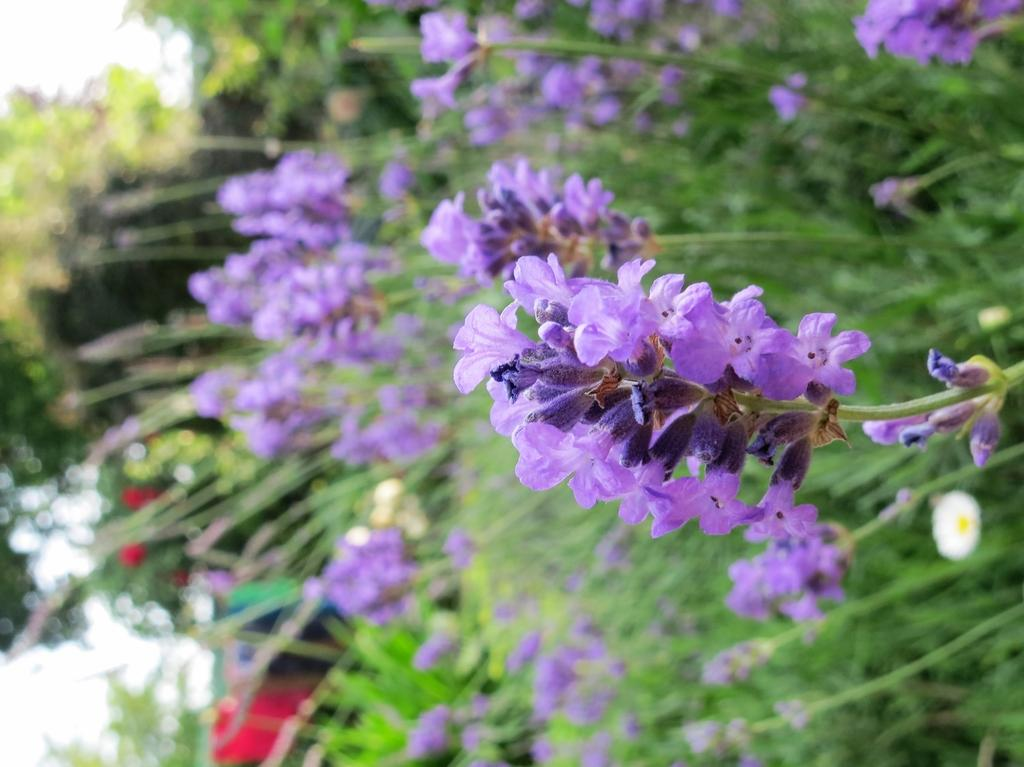What type of plants can be seen in the foreground of the image? There are flowering plants in the foreground of the image. Where might this image have been taken? The image appears to be taken in a garden. Can you describe the time of day when the image was taken? The image was likely taken during the day. What part of the natural environment is visible in the image? The sky is visible in the image. What type of teeth can be seen in the image? There are no teeth visible in the image; it features flowering plants in a garden. 